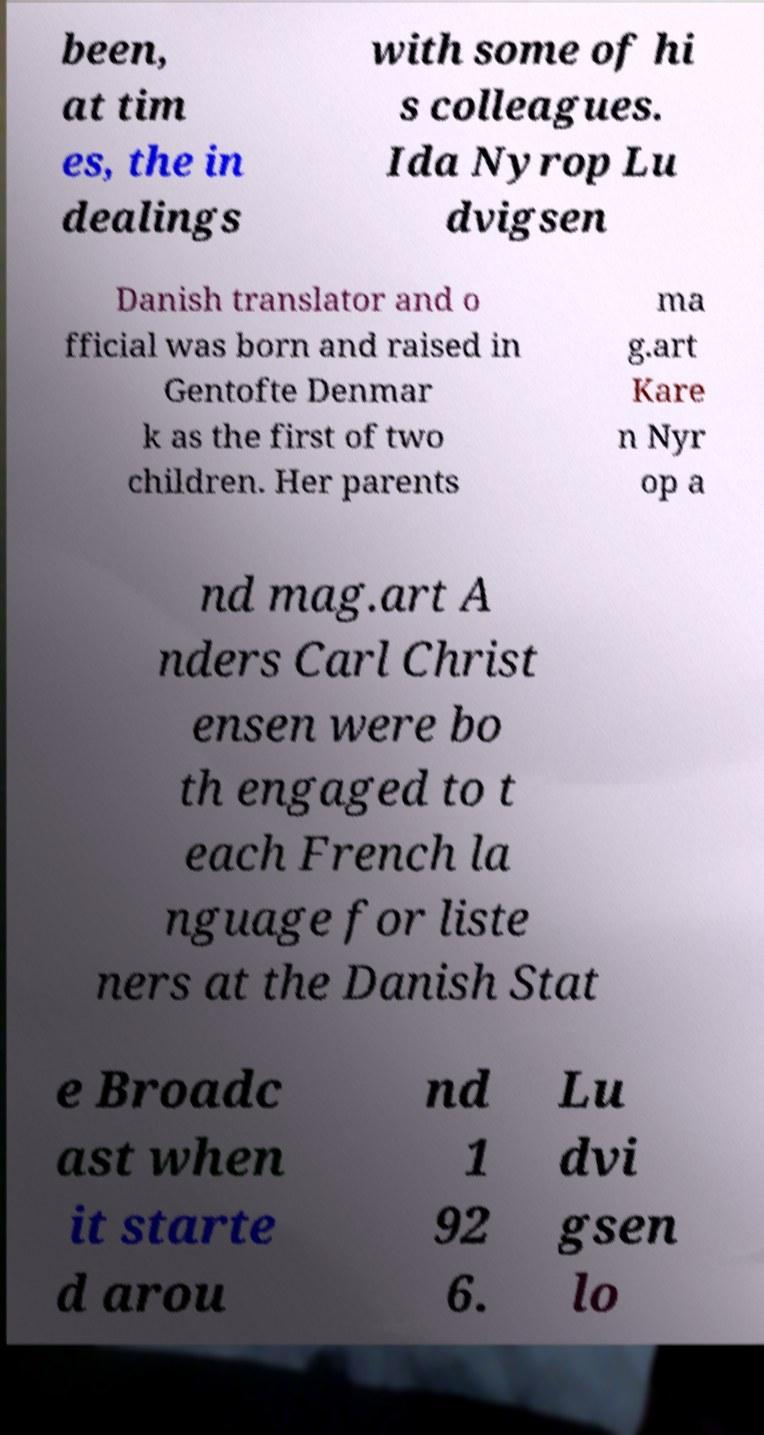Can you accurately transcribe the text from the provided image for me? been, at tim es, the in dealings with some of hi s colleagues. Ida Nyrop Lu dvigsen Danish translator and o fficial was born and raised in Gentofte Denmar k as the first of two children. Her parents ma g.art Kare n Nyr op a nd mag.art A nders Carl Christ ensen were bo th engaged to t each French la nguage for liste ners at the Danish Stat e Broadc ast when it starte d arou nd 1 92 6. Lu dvi gsen lo 